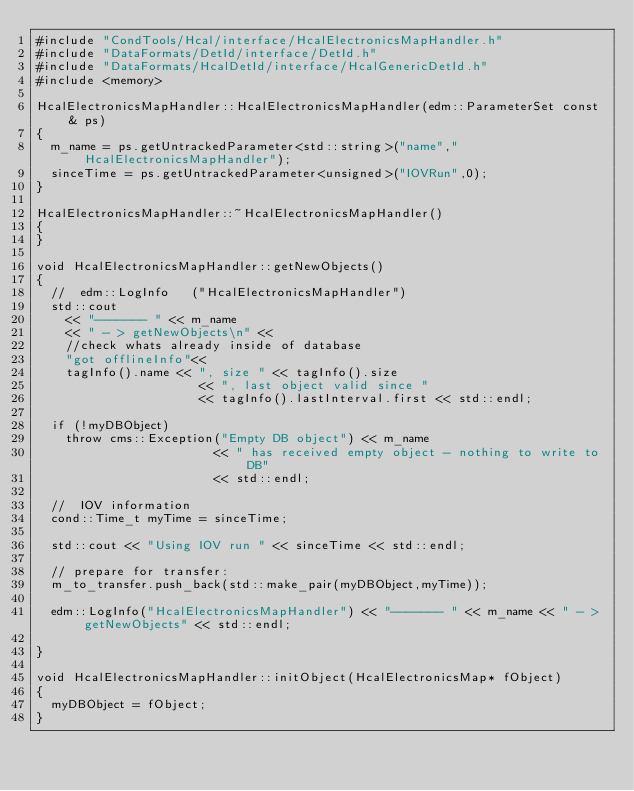Convert code to text. <code><loc_0><loc_0><loc_500><loc_500><_C++_>#include "CondTools/Hcal/interface/HcalElectronicsMapHandler.h"
#include "DataFormats/DetId/interface/DetId.h"
#include "DataFormats/HcalDetId/interface/HcalGenericDetId.h"
#include <memory>

HcalElectronicsMapHandler::HcalElectronicsMapHandler(edm::ParameterSet const & ps)
{
  m_name = ps.getUntrackedParameter<std::string>("name","HcalElectronicsMapHandler");
  sinceTime = ps.getUntrackedParameter<unsigned>("IOVRun",0);
}

HcalElectronicsMapHandler::~HcalElectronicsMapHandler()
{
}

void HcalElectronicsMapHandler::getNewObjects()
{
  //  edm::LogInfo   ("HcalElectronicsMapHandler") 
  std::cout
    << "------- " << m_name 
    << " - > getNewObjects\n" << 
    //check whats already inside of database
    "got offlineInfo"<<
    tagInfo().name << ", size " << tagInfo().size 
					  << ", last object valid since " 
					  << tagInfo().lastInterval.first << std::endl;  

  if (!myDBObject) 
    throw cms::Exception("Empty DB object") << m_name 
					    << " has received empty object - nothing to write to DB" 
					    << std::endl;

  //  IOV information
  cond::Time_t myTime = sinceTime;

  std::cout << "Using IOV run " << sinceTime << std::endl;

  // prepare for transfer:
  m_to_transfer.push_back(std::make_pair(myDBObject,myTime));

  edm::LogInfo("HcalElectronicsMapHandler") << "------- " << m_name << " - > getNewObjects" << std::endl;

}

void HcalElectronicsMapHandler::initObject(HcalElectronicsMap* fObject)
{
  myDBObject = fObject;
}
</code> 